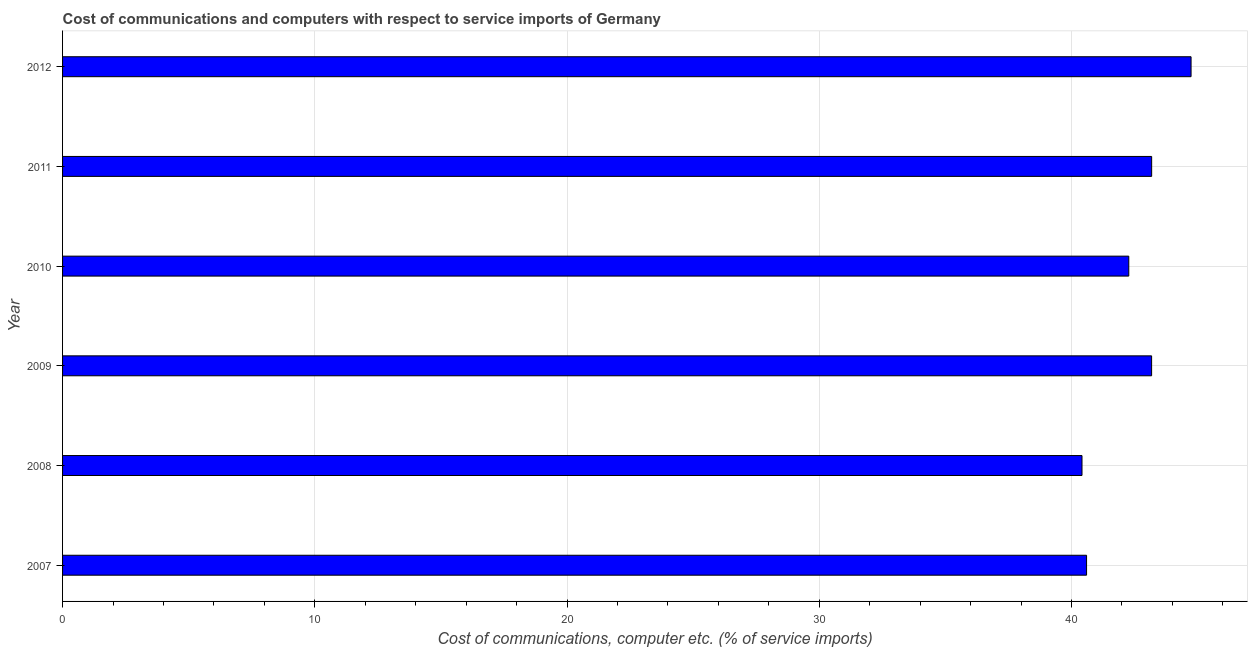What is the title of the graph?
Ensure brevity in your answer.  Cost of communications and computers with respect to service imports of Germany. What is the label or title of the X-axis?
Provide a short and direct response. Cost of communications, computer etc. (% of service imports). What is the cost of communications and computer in 2008?
Ensure brevity in your answer.  40.41. Across all years, what is the maximum cost of communications and computer?
Your response must be concise. 44.74. Across all years, what is the minimum cost of communications and computer?
Keep it short and to the point. 40.41. In which year was the cost of communications and computer maximum?
Provide a short and direct response. 2012. In which year was the cost of communications and computer minimum?
Provide a succinct answer. 2008. What is the sum of the cost of communications and computer?
Your answer should be very brief. 254.37. What is the difference between the cost of communications and computer in 2008 and 2012?
Make the answer very short. -4.32. What is the average cost of communications and computer per year?
Your response must be concise. 42.4. What is the median cost of communications and computer?
Offer a very short reply. 42.72. In how many years, is the cost of communications and computer greater than 14 %?
Your answer should be compact. 6. Do a majority of the years between 2009 and 2011 (inclusive) have cost of communications and computer greater than 26 %?
Give a very brief answer. Yes. What is the ratio of the cost of communications and computer in 2008 to that in 2009?
Give a very brief answer. 0.94. Is the difference between the cost of communications and computer in 2007 and 2012 greater than the difference between any two years?
Your answer should be compact. No. What is the difference between the highest and the second highest cost of communications and computer?
Make the answer very short. 1.56. Is the sum of the cost of communications and computer in 2010 and 2012 greater than the maximum cost of communications and computer across all years?
Offer a terse response. Yes. What is the difference between the highest and the lowest cost of communications and computer?
Ensure brevity in your answer.  4.32. Are all the bars in the graph horizontal?
Provide a short and direct response. Yes. What is the difference between two consecutive major ticks on the X-axis?
Keep it short and to the point. 10. Are the values on the major ticks of X-axis written in scientific E-notation?
Offer a very short reply. No. What is the Cost of communications, computer etc. (% of service imports) of 2007?
Make the answer very short. 40.6. What is the Cost of communications, computer etc. (% of service imports) of 2008?
Ensure brevity in your answer.  40.41. What is the Cost of communications, computer etc. (% of service imports) of 2009?
Keep it short and to the point. 43.17. What is the Cost of communications, computer etc. (% of service imports) of 2010?
Your answer should be very brief. 42.27. What is the Cost of communications, computer etc. (% of service imports) in 2011?
Provide a short and direct response. 43.18. What is the Cost of communications, computer etc. (% of service imports) in 2012?
Keep it short and to the point. 44.74. What is the difference between the Cost of communications, computer etc. (% of service imports) in 2007 and 2008?
Offer a very short reply. 0.18. What is the difference between the Cost of communications, computer etc. (% of service imports) in 2007 and 2009?
Your answer should be very brief. -2.58. What is the difference between the Cost of communications, computer etc. (% of service imports) in 2007 and 2010?
Offer a very short reply. -1.67. What is the difference between the Cost of communications, computer etc. (% of service imports) in 2007 and 2011?
Ensure brevity in your answer.  -2.58. What is the difference between the Cost of communications, computer etc. (% of service imports) in 2007 and 2012?
Ensure brevity in your answer.  -4.14. What is the difference between the Cost of communications, computer etc. (% of service imports) in 2008 and 2009?
Offer a very short reply. -2.76. What is the difference between the Cost of communications, computer etc. (% of service imports) in 2008 and 2010?
Keep it short and to the point. -1.85. What is the difference between the Cost of communications, computer etc. (% of service imports) in 2008 and 2011?
Provide a short and direct response. -2.76. What is the difference between the Cost of communications, computer etc. (% of service imports) in 2008 and 2012?
Make the answer very short. -4.32. What is the difference between the Cost of communications, computer etc. (% of service imports) in 2009 and 2010?
Provide a short and direct response. 0.91. What is the difference between the Cost of communications, computer etc. (% of service imports) in 2009 and 2011?
Make the answer very short. -0. What is the difference between the Cost of communications, computer etc. (% of service imports) in 2009 and 2012?
Make the answer very short. -1.56. What is the difference between the Cost of communications, computer etc. (% of service imports) in 2010 and 2011?
Give a very brief answer. -0.91. What is the difference between the Cost of communications, computer etc. (% of service imports) in 2010 and 2012?
Offer a very short reply. -2.47. What is the difference between the Cost of communications, computer etc. (% of service imports) in 2011 and 2012?
Offer a terse response. -1.56. What is the ratio of the Cost of communications, computer etc. (% of service imports) in 2007 to that in 2011?
Your answer should be compact. 0.94. What is the ratio of the Cost of communications, computer etc. (% of service imports) in 2007 to that in 2012?
Offer a very short reply. 0.91. What is the ratio of the Cost of communications, computer etc. (% of service imports) in 2008 to that in 2009?
Give a very brief answer. 0.94. What is the ratio of the Cost of communications, computer etc. (% of service imports) in 2008 to that in 2010?
Your response must be concise. 0.96. What is the ratio of the Cost of communications, computer etc. (% of service imports) in 2008 to that in 2011?
Keep it short and to the point. 0.94. What is the ratio of the Cost of communications, computer etc. (% of service imports) in 2008 to that in 2012?
Provide a short and direct response. 0.9. What is the ratio of the Cost of communications, computer etc. (% of service imports) in 2009 to that in 2011?
Ensure brevity in your answer.  1. What is the ratio of the Cost of communications, computer etc. (% of service imports) in 2010 to that in 2012?
Make the answer very short. 0.94. 